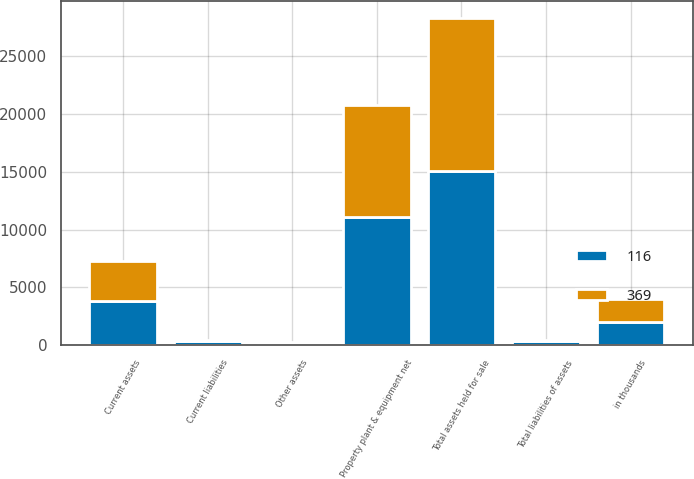<chart> <loc_0><loc_0><loc_500><loc_500><stacked_bar_chart><ecel><fcel>in thousands<fcel>Current assets<fcel>Property plant & equipment net<fcel>Other assets<fcel>Total assets held for sale<fcel>Current liabilities<fcel>Total liabilities of assets<nl><fcel>369<fcel>2010<fcel>3460<fcel>9625<fcel>122<fcel>13207<fcel>116<fcel>116<nl><fcel>116<fcel>2009<fcel>3799<fcel>11117<fcel>156<fcel>15072<fcel>369<fcel>369<nl></chart> 